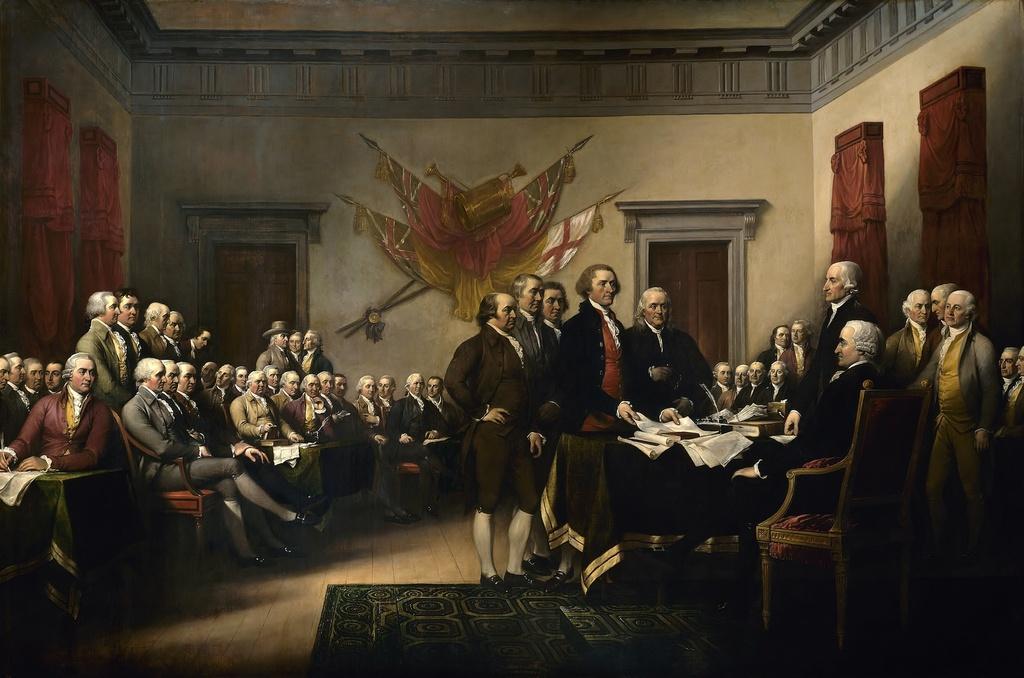In one or two sentences, can you explain what this image depicts? In this image I can see it is a painting, on the right side a man is sitting on the chair near the table. In the middle a group of people are sitting on the chairs and looking at the right side. At the bottom it looks like a floor mat. 